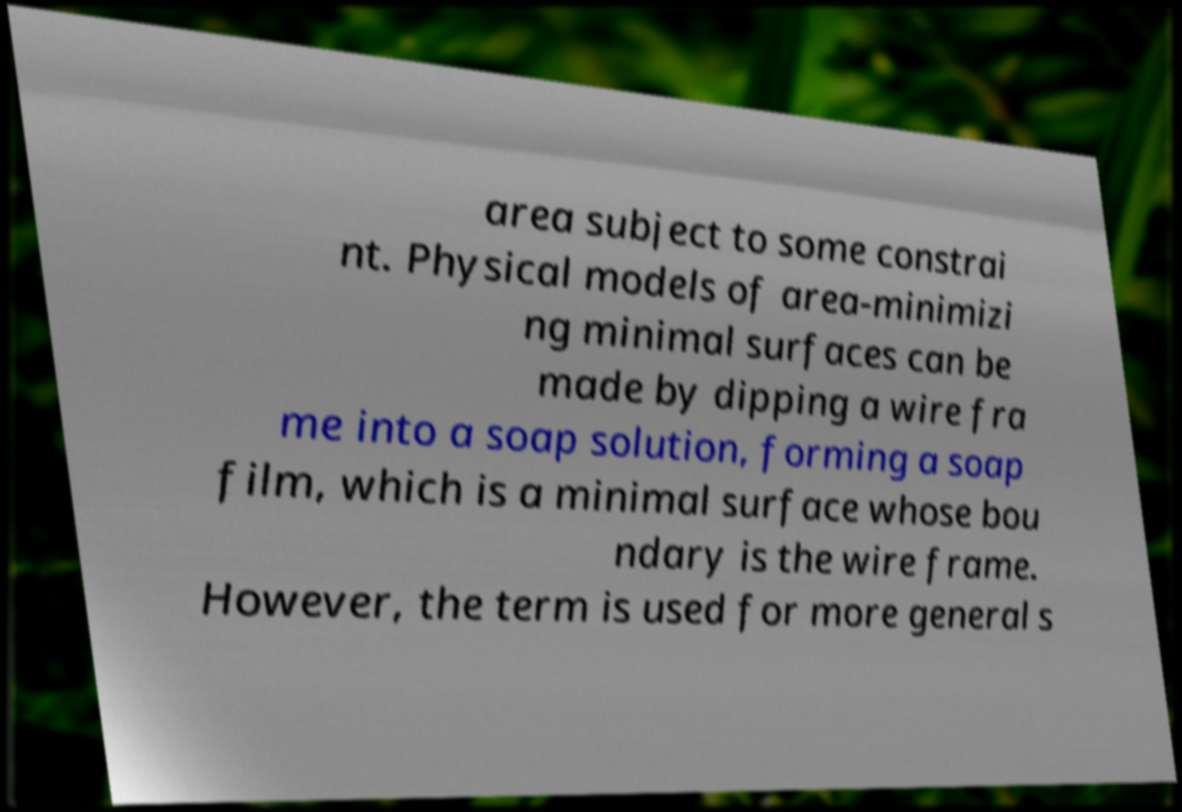I need the written content from this picture converted into text. Can you do that? area subject to some constrai nt. Physical models of area-minimizi ng minimal surfaces can be made by dipping a wire fra me into a soap solution, forming a soap film, which is a minimal surface whose bou ndary is the wire frame. However, the term is used for more general s 